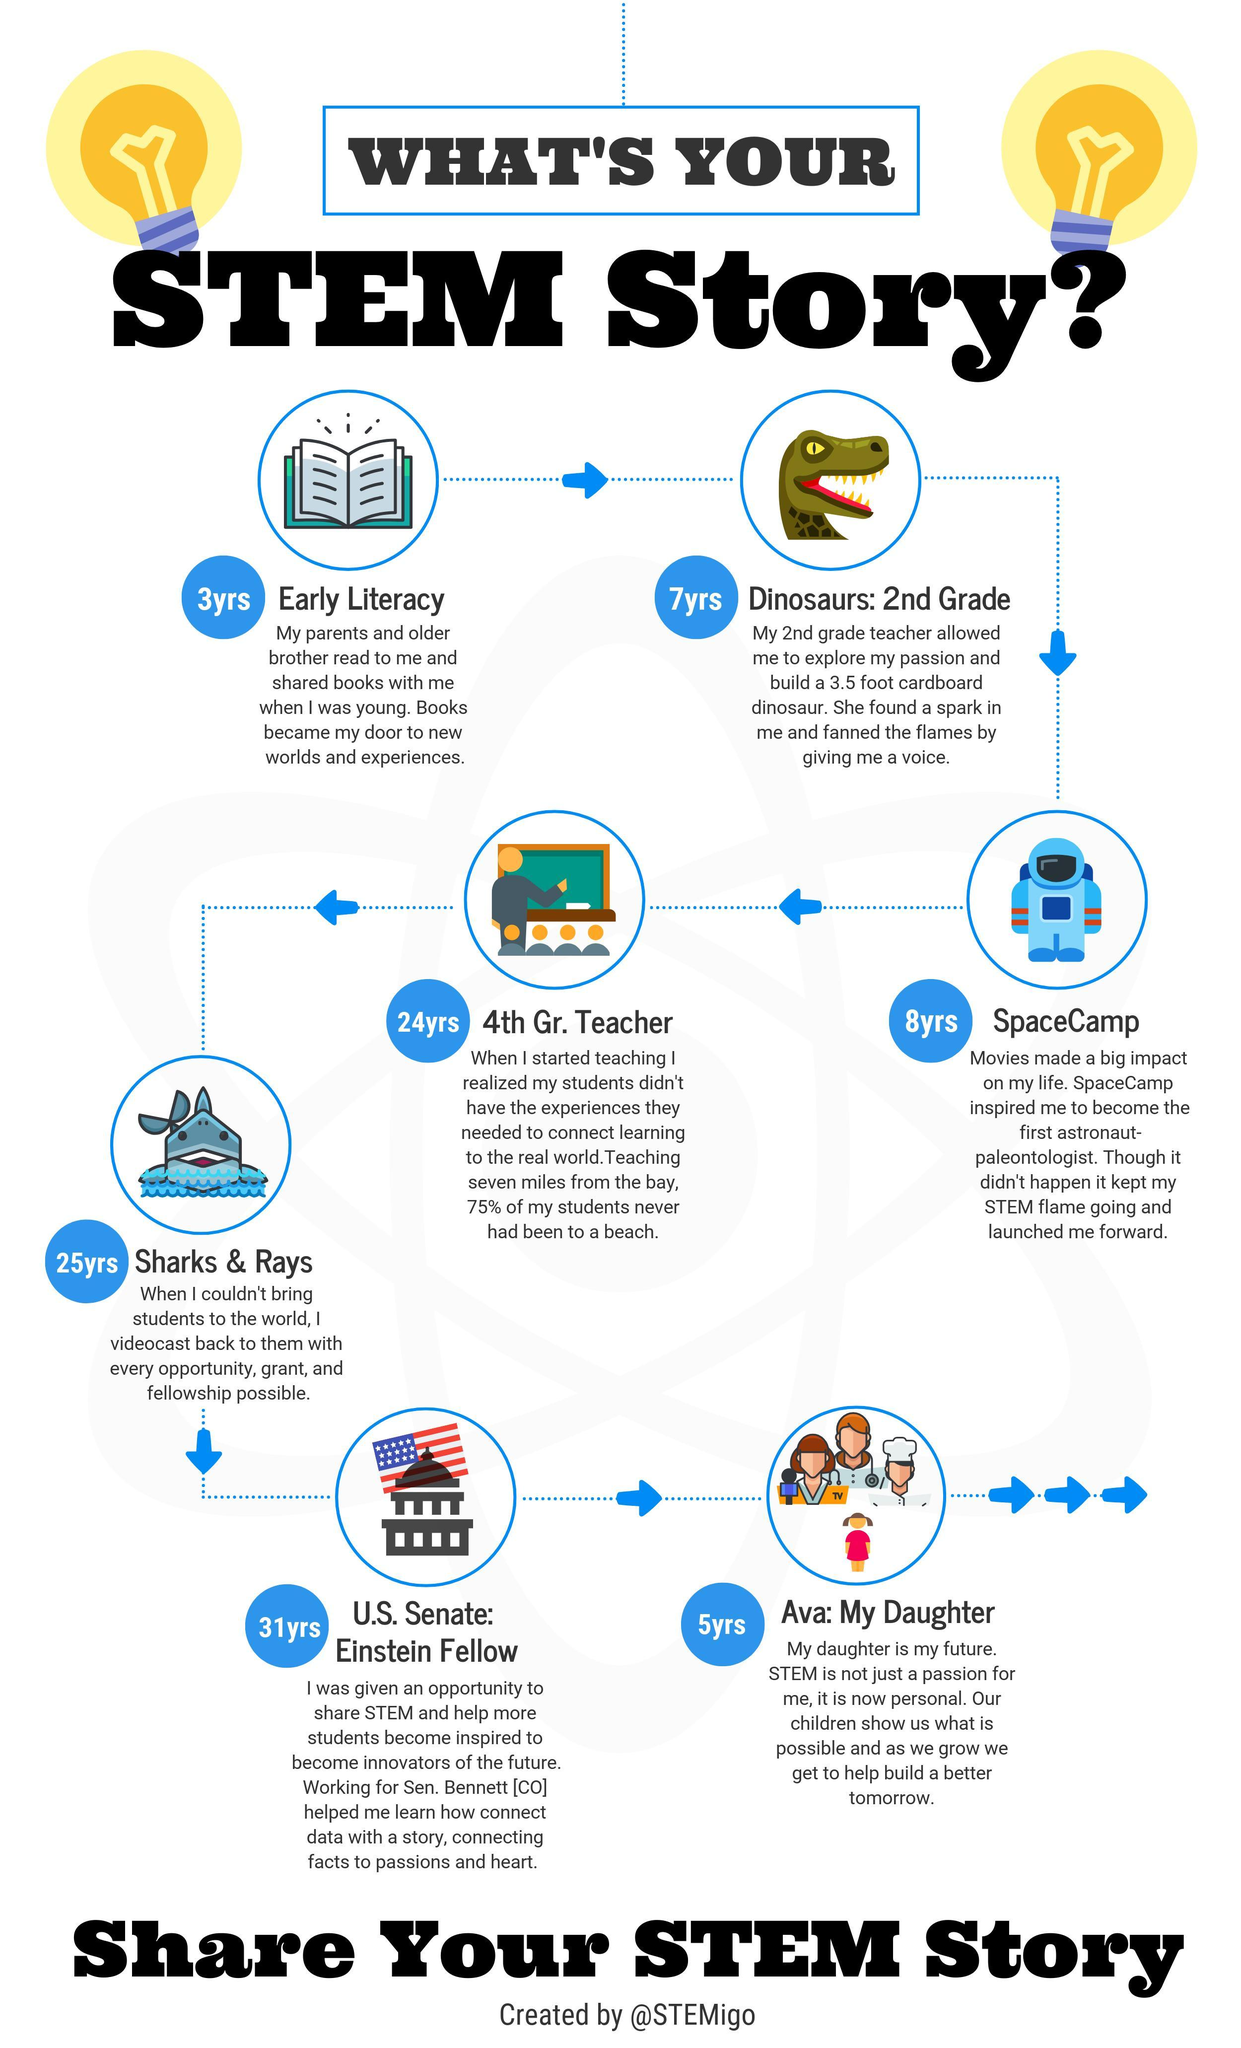What is the topic of the STEM story of 25 years old?
Answer the question with a short phrase. sharks & rays With which age the timeline begins? 3 How many icons of book are given in this infographic? 1 How many arrow icons are given in this infographic? 9 What is the color of the text "stem story" in the heading - black or white? black What is the topic of the STEM story of 3 years old? Early literacy What is the topic given below the book icon? Early literacy What is the topic of the STEM story of 24 years old? 4th Gr. teacher how many vector images of bulbs are given near the heading? 2 What is the topic of the STEM story of 8 years old? spacecamp 